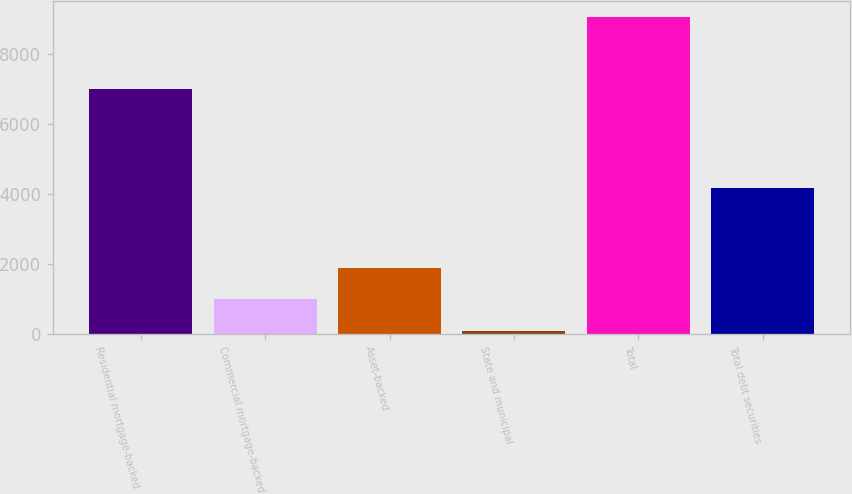Convert chart to OTSL. <chart><loc_0><loc_0><loc_500><loc_500><bar_chart><fcel>Residential mortgage-backed<fcel>Commercial mortgage-backed<fcel>Asset-backed<fcel>State and municipal<fcel>Total<fcel>Total debt securities<nl><fcel>6994<fcel>976.1<fcel>1873.2<fcel>79<fcel>9050<fcel>4151<nl></chart> 